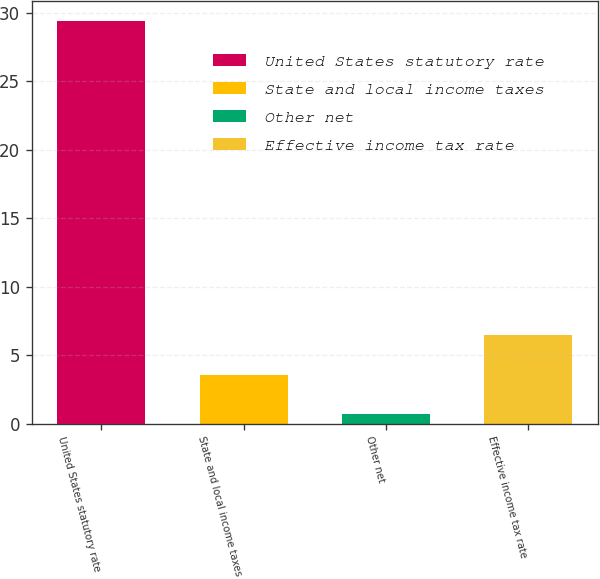Convert chart to OTSL. <chart><loc_0><loc_0><loc_500><loc_500><bar_chart><fcel>United States statutory rate<fcel>State and local income taxes<fcel>Other net<fcel>Effective income tax rate<nl><fcel>29.4<fcel>3.57<fcel>0.7<fcel>6.44<nl></chart> 